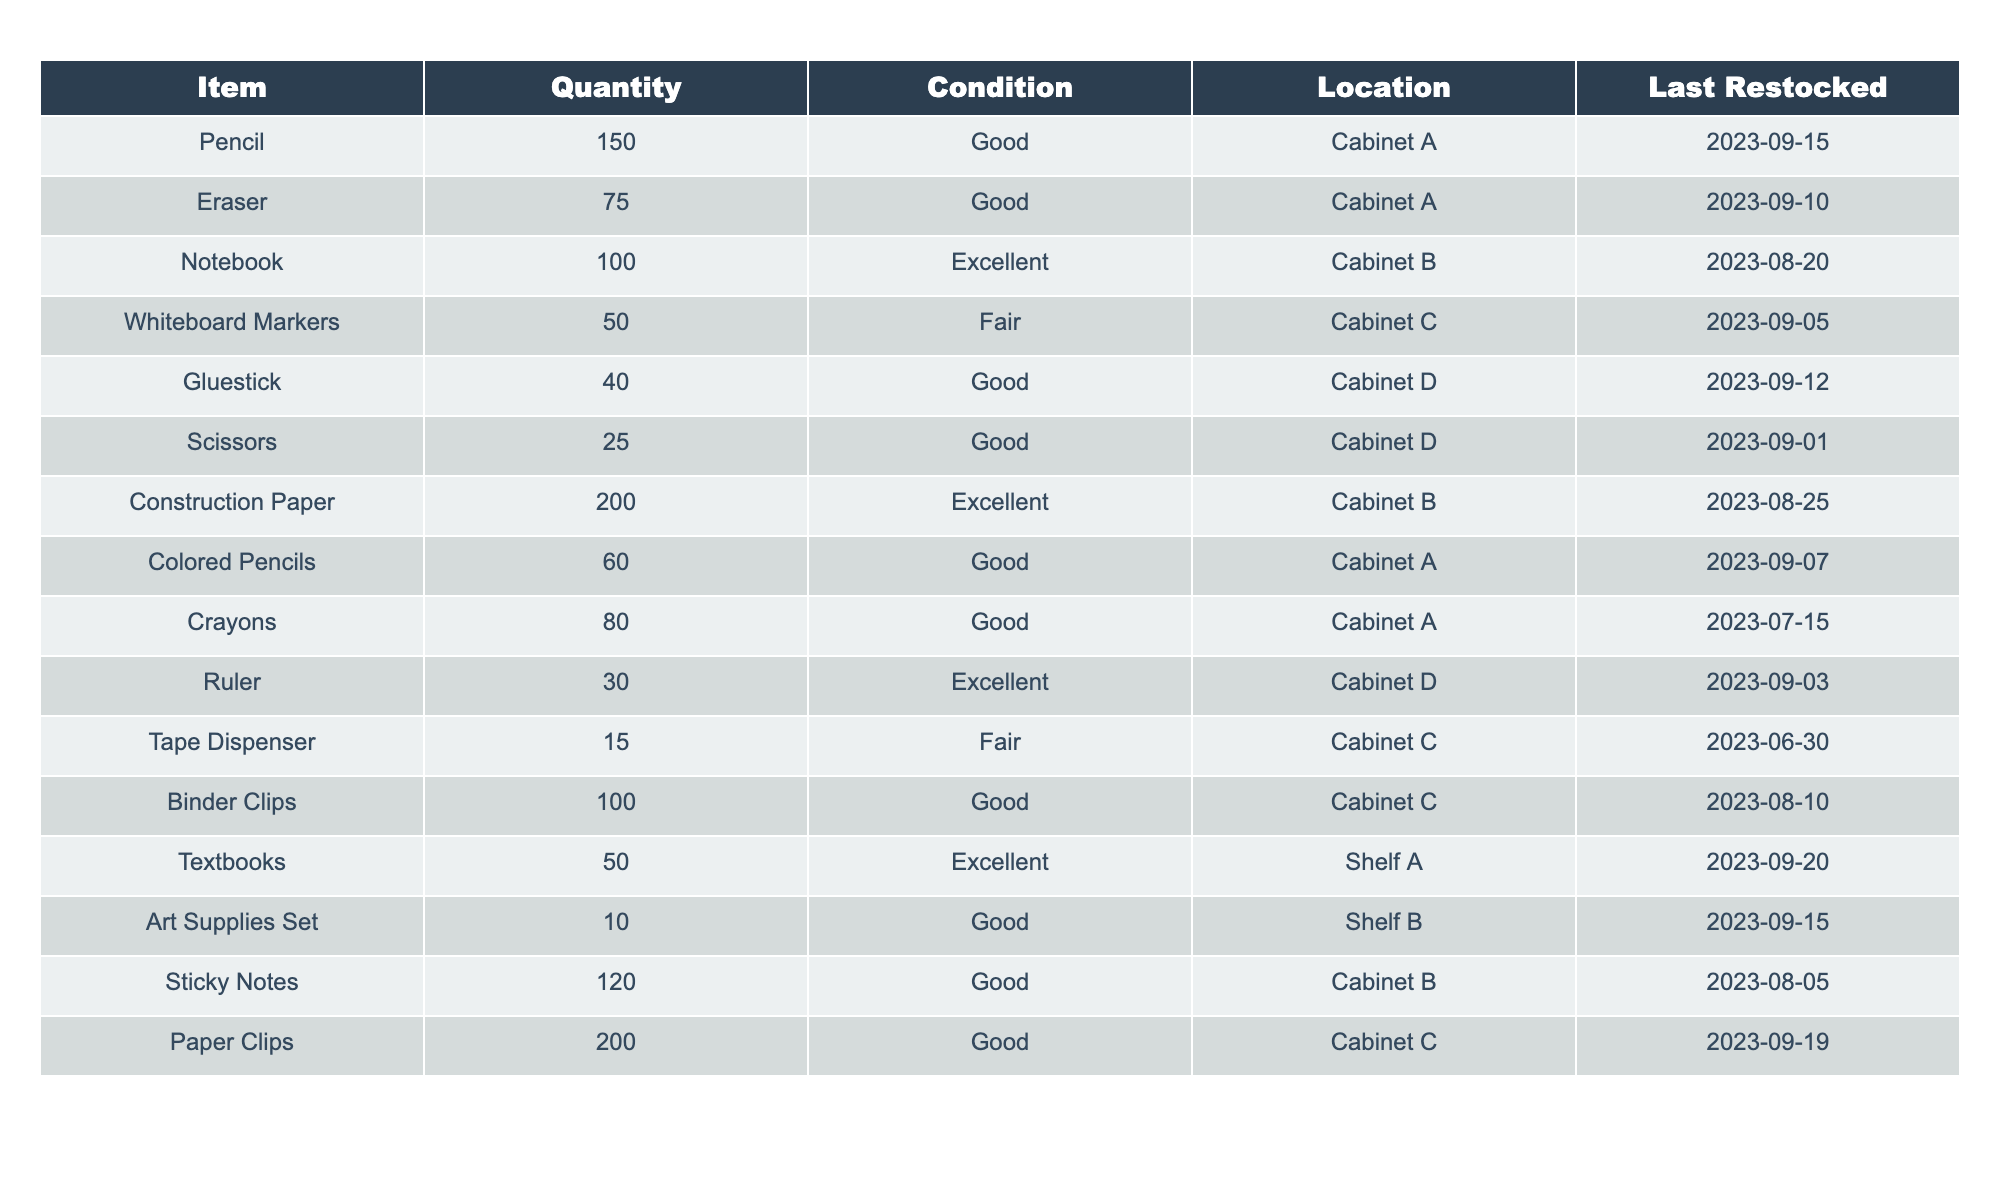What is the quantity of erasers in the classroom supplies? The table lists the item "Eraser" and shows that the quantity is 75.
Answer: 75 How many more pencils are there compared to scissors? Pencils are listed with a quantity of 150 and scissors have a quantity of 25. The difference is 150 - 25 = 125.
Answer: 125 Are there more colored pencils or crayons available? The table shows that there are 60 colored pencils and 80 crayons. Since 80 is greater than 60, there are more crayons.
Answer: Yes, there are more crayons What is the total number of gluesticks and scissors combined? Gluesticks have a quantity of 40 and scissors have a quantity of 25. Adding these gives 40 + 25 = 65.
Answer: 65 Which item has the least quantity in stock? Looking through the quantities listed, the item with the least quantity is the "Art Supplies Set," which has 10.
Answer: Art Supplies Set What is the average quantity of the supplies located in Cabinet A? The items in Cabinet A are Pencil (150), Colored Pencils (60), and Crayons (80). The average is calculated as (150 + 60 + 80) / 3 = 290 / 3 = 96.67, which can be rounded to 97.
Answer: 97 Is the total quantity of good condition items greater than fair condition items? Items in good condition: Pencil (150), Eraser (75), Notebook (100), Gluestick (40), Scissors (25), Colored Pencils (60), Crayons (80), Binder Clips (100), Sticky Notes (120), Art Supplies Set (10) totaling 730. Items in fair condition: Whiteboard Markers (50), Tape Dispenser (15) totaling 65. Since 730 > 65, the statement is true.
Answer: Yes What is the quantity difference between the highest and lowest quantity items? The highest quantity item is "Construction Paper" with 200, and the lowest is "Art Supplies Set" with 10. The difference is 200 - 10 = 190.
Answer: 190 How many items were last restocked on or after September 10, 2023? Reviewing the last restocked dates, the items restocked on or after September 10 are Pencil, Eraser, Whiteboard Markers, Gluestick, Scissors, Colored Pencils, and Textbooks. There are 7 items.
Answer: 7 Which cabinet contains more total supplies: Cabinet A or Cabinet B? Cabinet A has Pencil (150), Eraser (75), Colored Pencils (60), and Crayons (80) totaling 365. Cabinet B has Notebook (100), Construction Paper (200), and Sticky Notes (120) totaling 420. Since 420 > 365, Cabinet B contains more supplies.
Answer: Cabinet B 